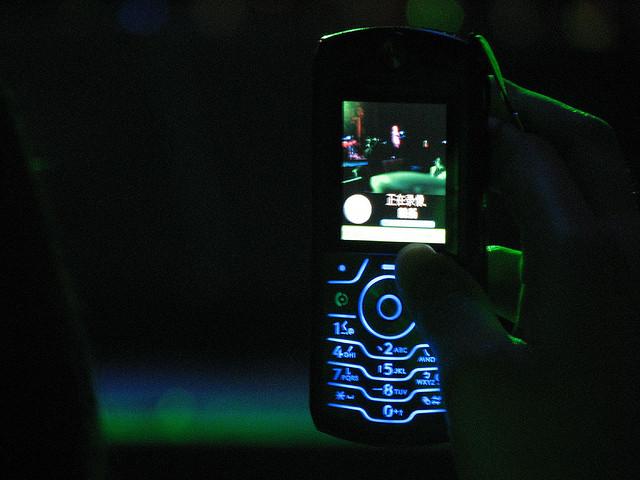Is this a current cell phone?
Answer briefly. No. Is this a piano?
Answer briefly. No. Is this phone American?
Write a very short answer. No. 